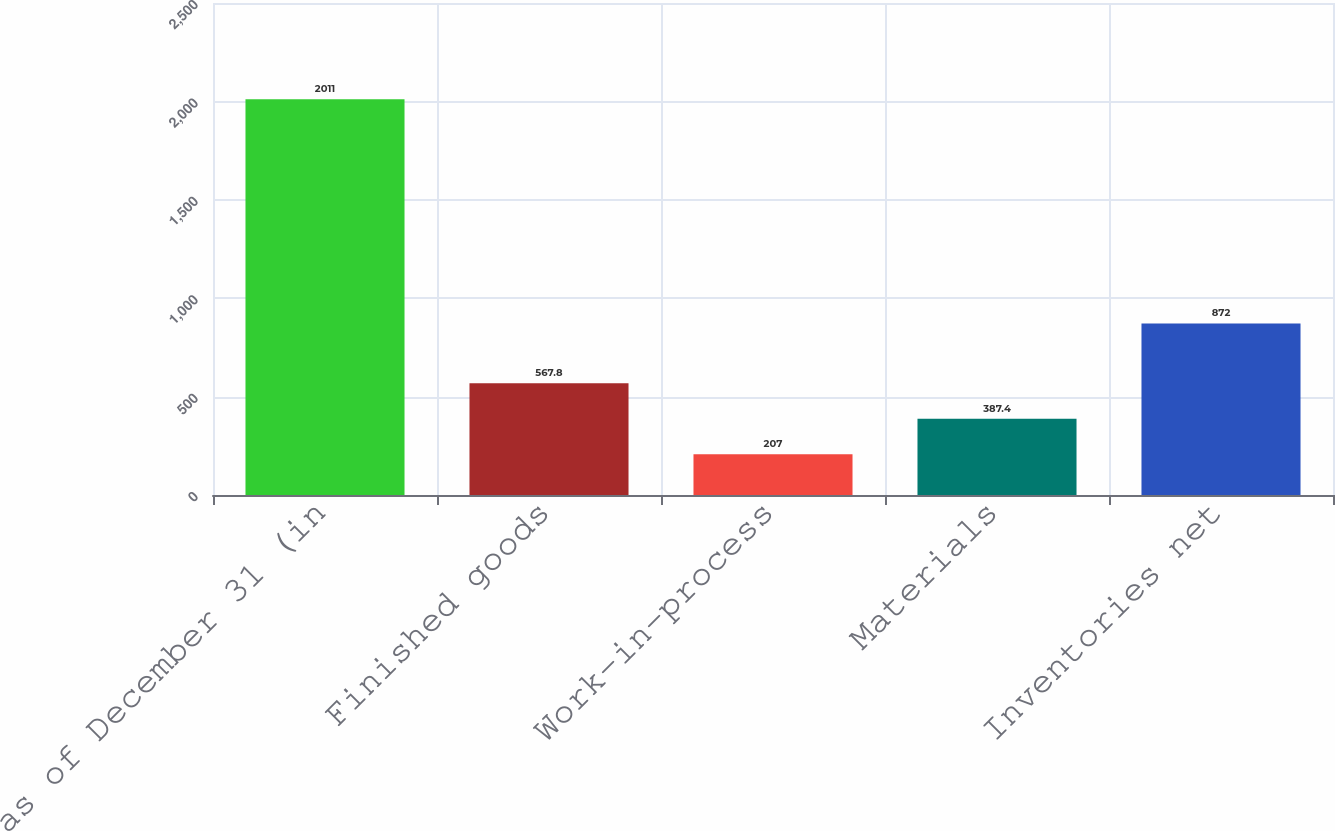Convert chart. <chart><loc_0><loc_0><loc_500><loc_500><bar_chart><fcel>as of December 31 (in<fcel>Finished goods<fcel>Work-in-process<fcel>Materials<fcel>Inventories net<nl><fcel>2011<fcel>567.8<fcel>207<fcel>387.4<fcel>872<nl></chart> 